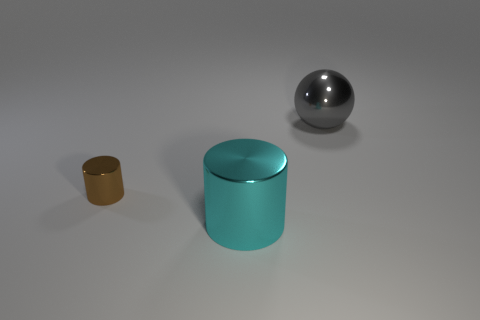Subtract 1 cylinders. How many cylinders are left? 1 Add 3 tiny shiny cylinders. How many objects exist? 6 Subtract all cylinders. How many objects are left? 1 Subtract all brown spheres. Subtract all gray blocks. How many spheres are left? 1 Subtract all yellow cubes. How many blue spheres are left? 0 Subtract all big red cylinders. Subtract all big shiny balls. How many objects are left? 2 Add 1 shiny cylinders. How many shiny cylinders are left? 3 Add 3 cylinders. How many cylinders exist? 5 Subtract all brown cylinders. How many cylinders are left? 1 Subtract 0 gray cylinders. How many objects are left? 3 